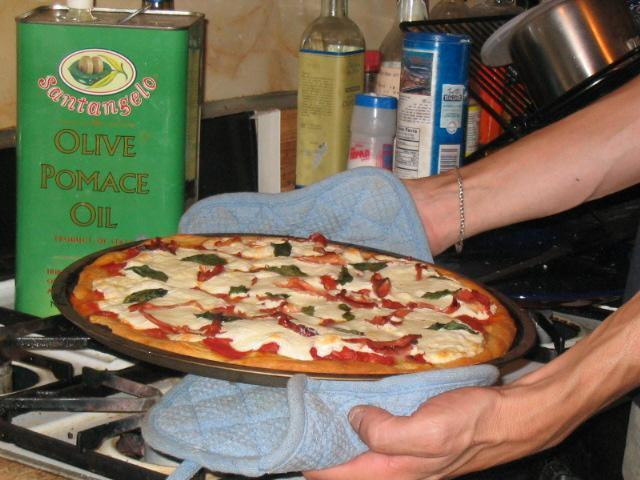How many pots in the picture?
Give a very brief answer. 1. How many ovens are in the photo?
Give a very brief answer. 2. How many bottles are visible?
Give a very brief answer. 3. How many cars are driving down this road?
Give a very brief answer. 0. 